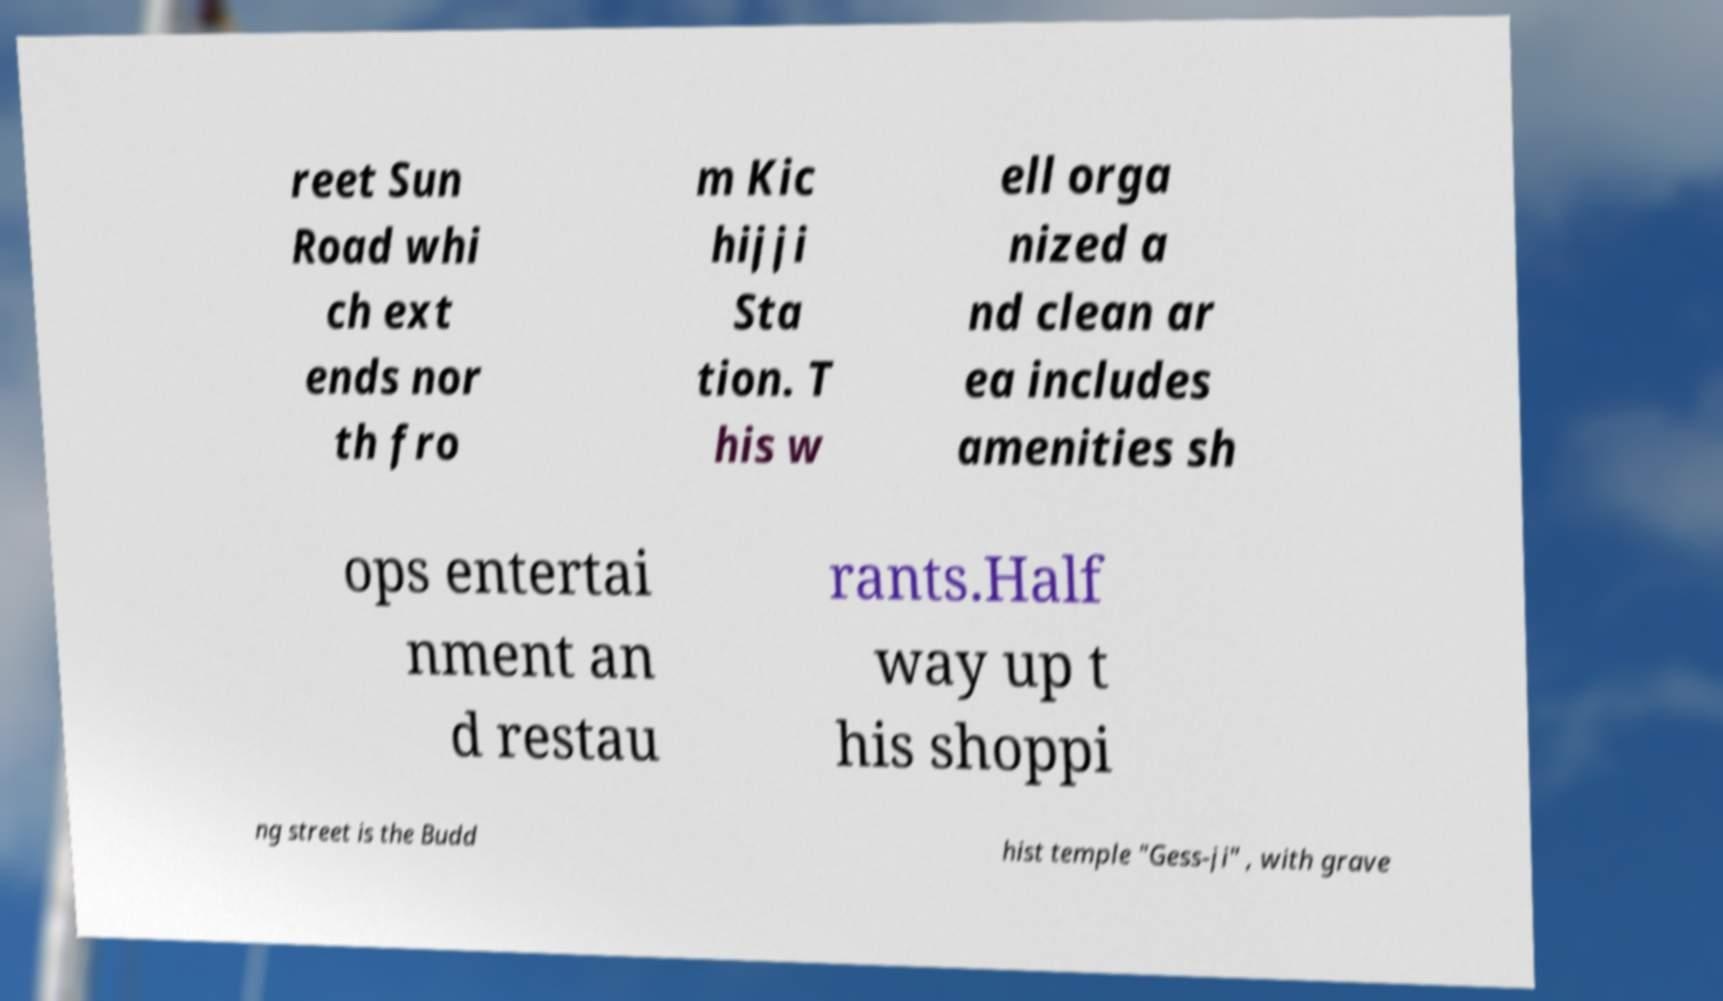Can you read and provide the text displayed in the image?This photo seems to have some interesting text. Can you extract and type it out for me? reet Sun Road whi ch ext ends nor th fro m Kic hijji Sta tion. T his w ell orga nized a nd clean ar ea includes amenities sh ops entertai nment an d restau rants.Half way up t his shoppi ng street is the Budd hist temple "Gess-ji" , with grave 